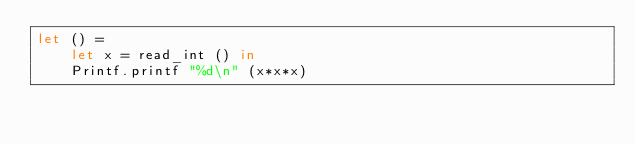Convert code to text. <code><loc_0><loc_0><loc_500><loc_500><_OCaml_>let () =
    let x = read_int () in
    Printf.printf "%d\n" (x*x*x)
</code> 